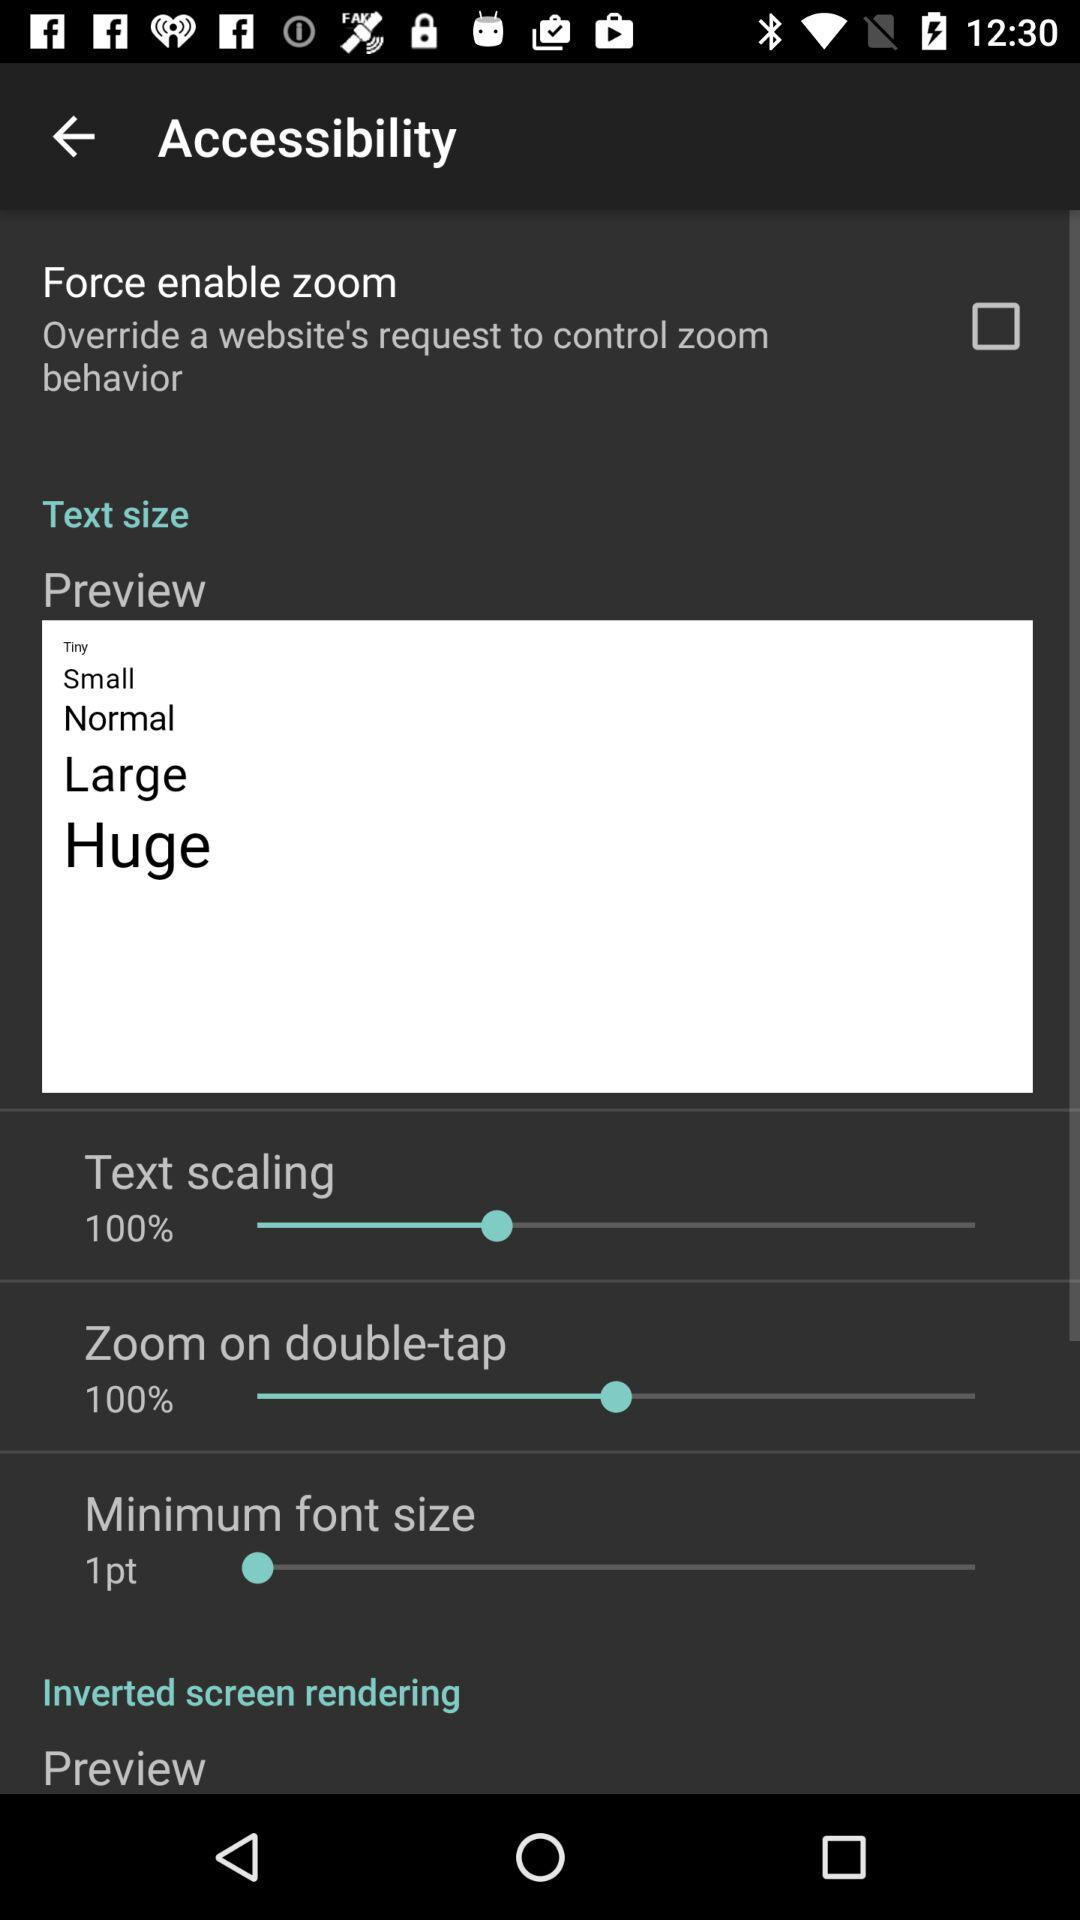What is the status of "Force enable zoom"? The status is "off". 